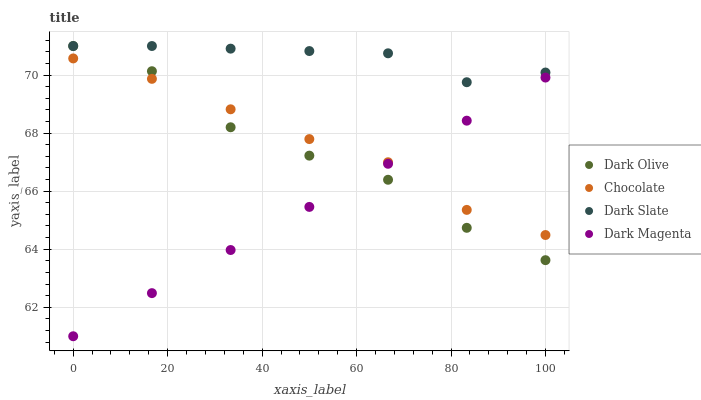Does Dark Magenta have the minimum area under the curve?
Answer yes or no. Yes. Does Dark Slate have the maximum area under the curve?
Answer yes or no. Yes. Does Dark Olive have the minimum area under the curve?
Answer yes or no. No. Does Dark Olive have the maximum area under the curve?
Answer yes or no. No. Is Dark Magenta the smoothest?
Answer yes or no. Yes. Is Dark Olive the roughest?
Answer yes or no. Yes. Is Dark Olive the smoothest?
Answer yes or no. No. Is Dark Magenta the roughest?
Answer yes or no. No. Does Dark Magenta have the lowest value?
Answer yes or no. Yes. Does Dark Olive have the lowest value?
Answer yes or no. No. Does Dark Olive have the highest value?
Answer yes or no. Yes. Does Dark Magenta have the highest value?
Answer yes or no. No. Is Chocolate less than Dark Slate?
Answer yes or no. Yes. Is Dark Slate greater than Dark Magenta?
Answer yes or no. Yes. Does Dark Magenta intersect Chocolate?
Answer yes or no. Yes. Is Dark Magenta less than Chocolate?
Answer yes or no. No. Is Dark Magenta greater than Chocolate?
Answer yes or no. No. Does Chocolate intersect Dark Slate?
Answer yes or no. No. 